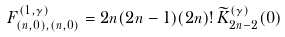Convert formula to latex. <formula><loc_0><loc_0><loc_500><loc_500>F _ { ( n , 0 ) , ( n , 0 ) } ^ { ( 1 , \gamma ) } = 2 n ( 2 n - 1 ) ( 2 n ) ! \, \widetilde { K } _ { 2 n - 2 } ^ { ( \gamma ) } ( 0 )</formula> 